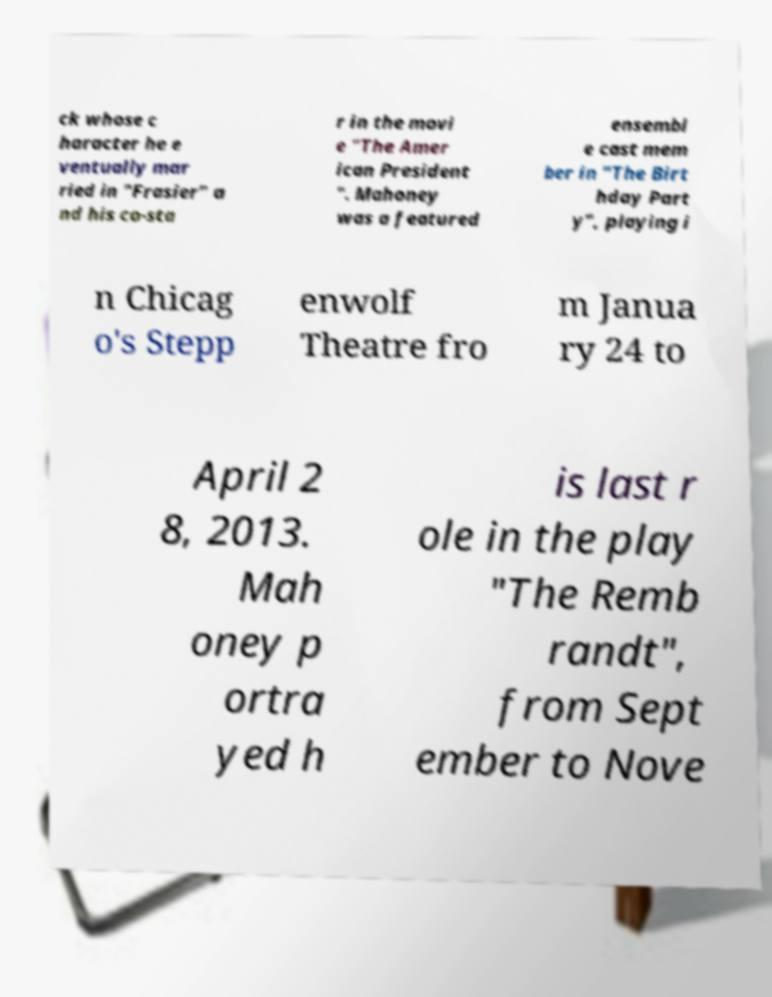Could you extract and type out the text from this image? ck whose c haracter he e ventually mar ried in "Frasier" a nd his co-sta r in the movi e "The Amer ican President ". Mahoney was a featured ensembl e cast mem ber in "The Birt hday Part y", playing i n Chicag o's Stepp enwolf Theatre fro m Janua ry 24 to April 2 8, 2013. Mah oney p ortra yed h is last r ole in the play "The Remb randt", from Sept ember to Nove 